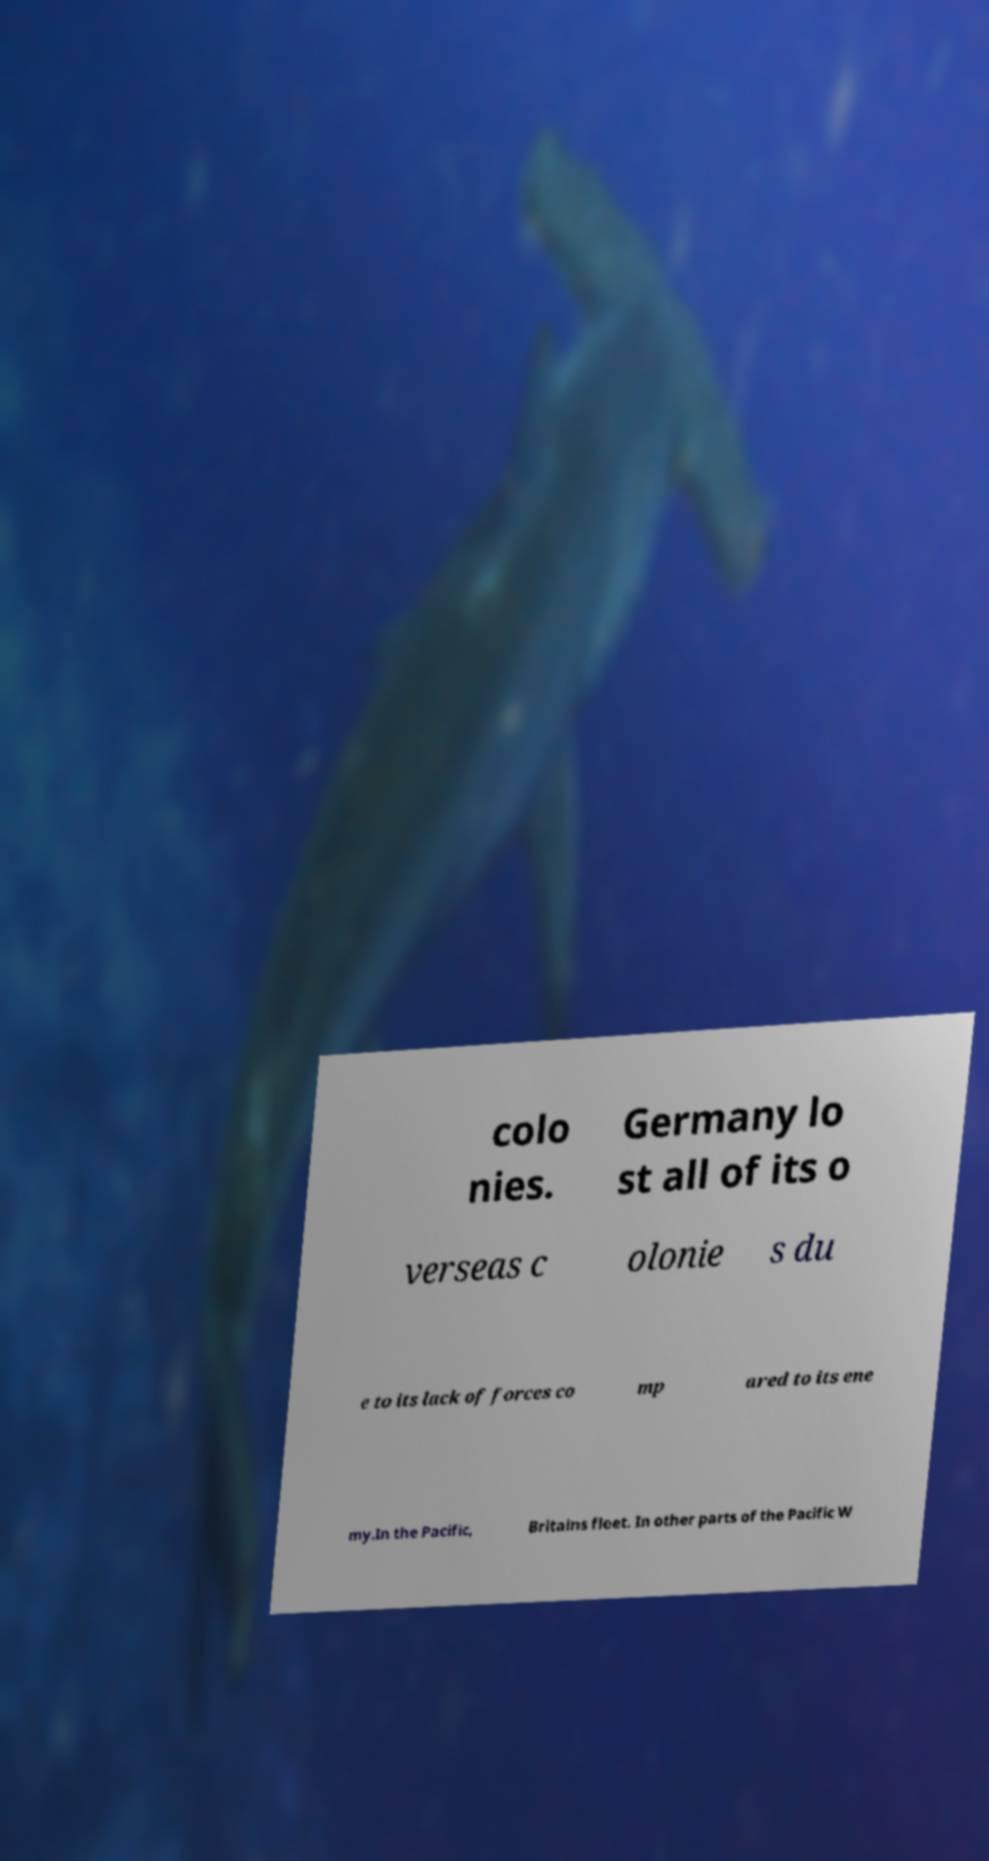What messages or text are displayed in this image? I need them in a readable, typed format. colo nies. Germany lo st all of its o verseas c olonie s du e to its lack of forces co mp ared to its ene my.In the Pacific, Britains fleet. In other parts of the Pacific W 